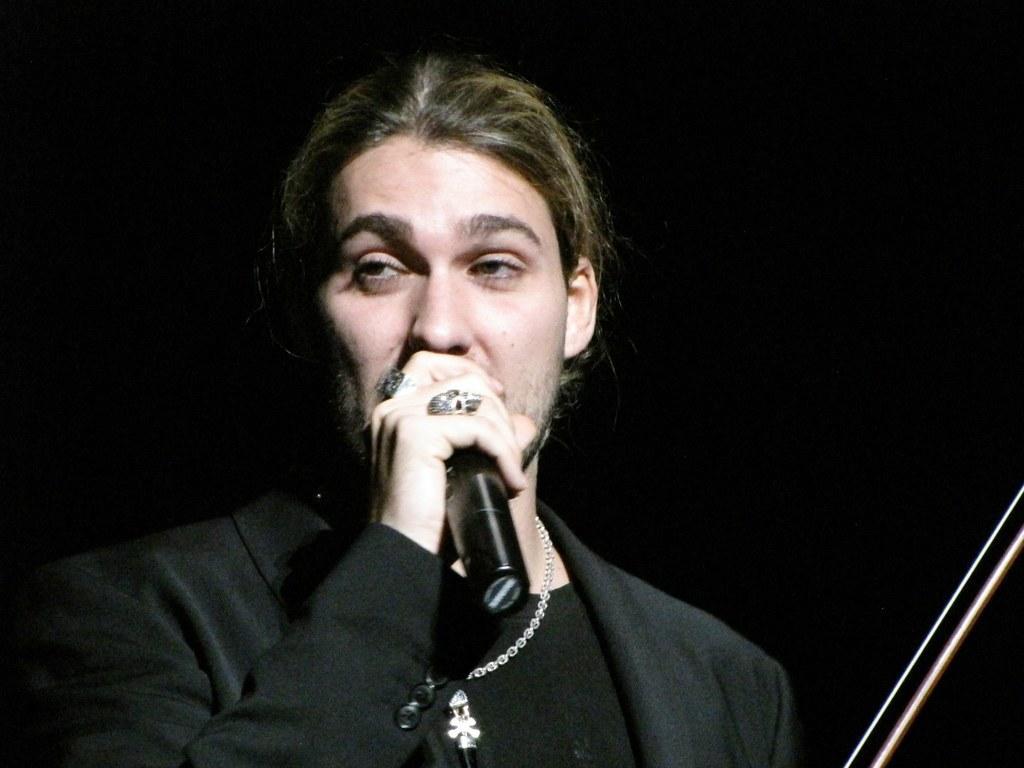How would you summarize this image in a sentence or two? In this image we can see a man holding the mike and the background is in black color. 